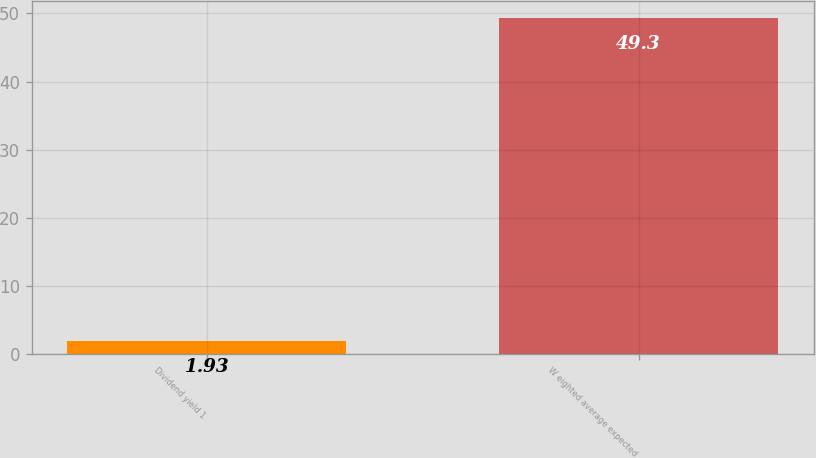<chart> <loc_0><loc_0><loc_500><loc_500><bar_chart><fcel>Dividend yield 1<fcel>W eighted average expected<nl><fcel>1.93<fcel>49.3<nl></chart> 